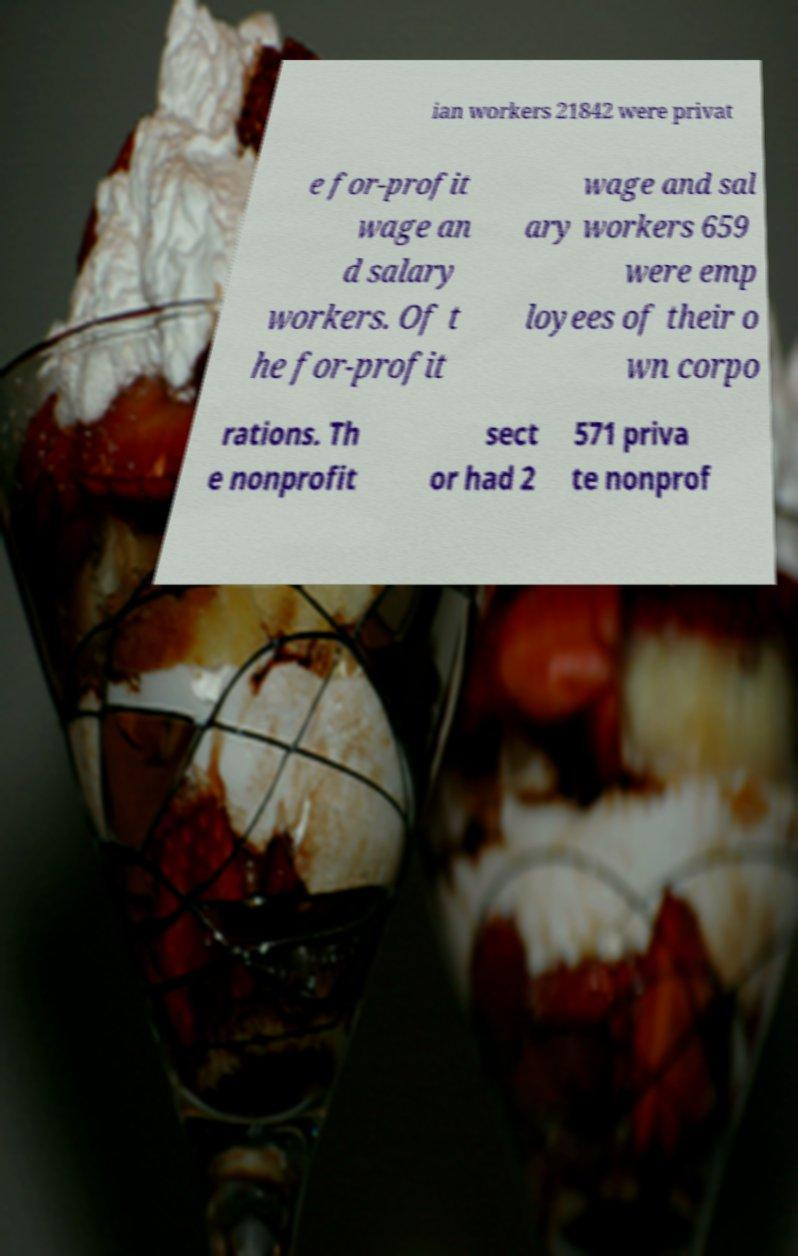There's text embedded in this image that I need extracted. Can you transcribe it verbatim? ian workers 21842 were privat e for-profit wage an d salary workers. Of t he for-profit wage and sal ary workers 659 were emp loyees of their o wn corpo rations. Th e nonprofit sect or had 2 571 priva te nonprof 